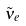<formula> <loc_0><loc_0><loc_500><loc_500>\tilde { \nu } _ { e }</formula> 